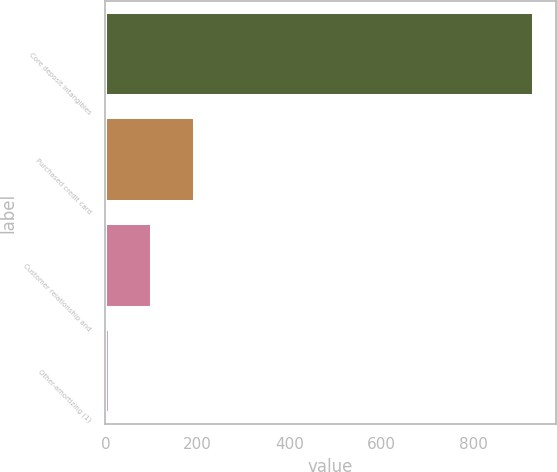<chart> <loc_0><loc_0><loc_500><loc_500><bar_chart><fcel>Core deposit intangibles<fcel>Purchased credit card<fcel>Customer relationship and<fcel>Other-amortizing (1)<nl><fcel>932<fcel>194.4<fcel>102.2<fcel>10<nl></chart> 